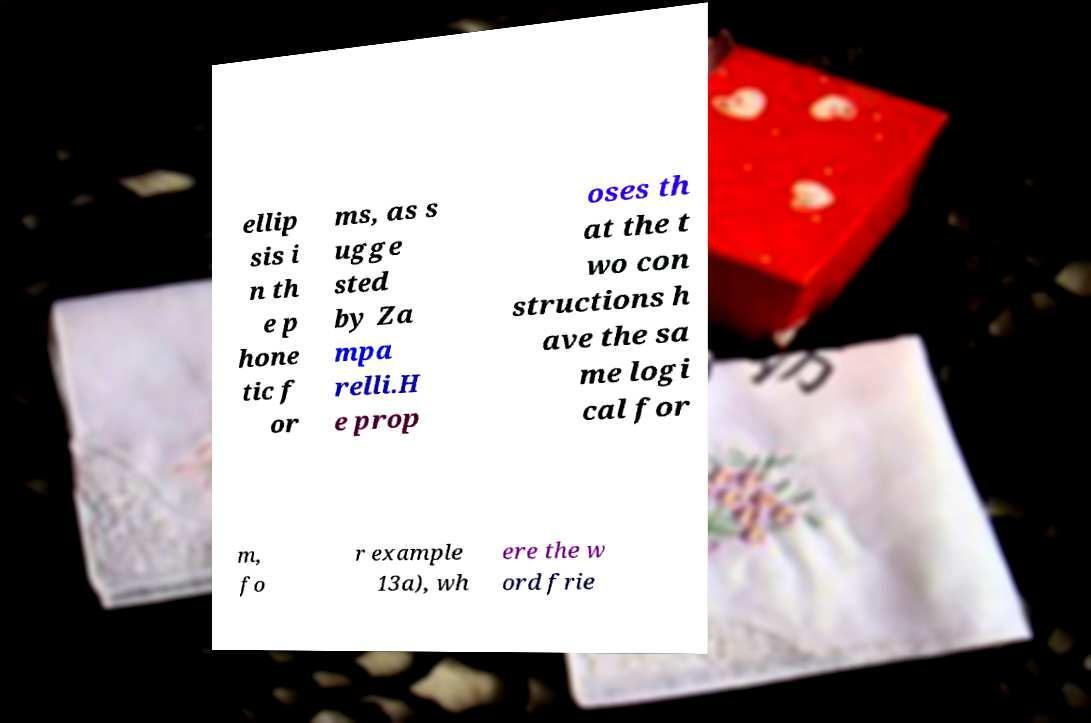Could you assist in decoding the text presented in this image and type it out clearly? ellip sis i n th e p hone tic f or ms, as s ugge sted by Za mpa relli.H e prop oses th at the t wo con structions h ave the sa me logi cal for m, fo r example 13a), wh ere the w ord frie 